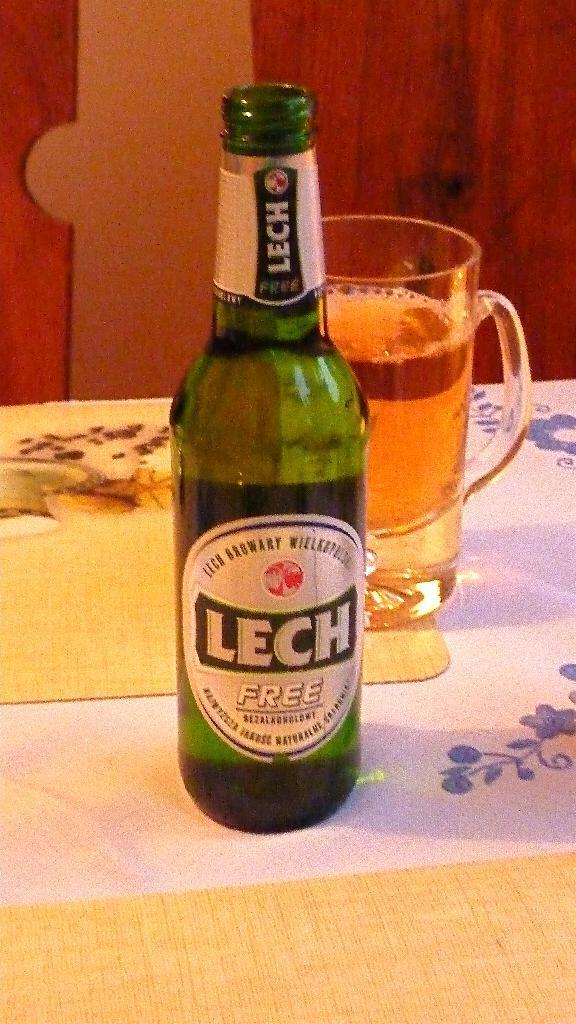Can you describe this image briefly? This picture shows a beer bottle and a beer glass on the table 